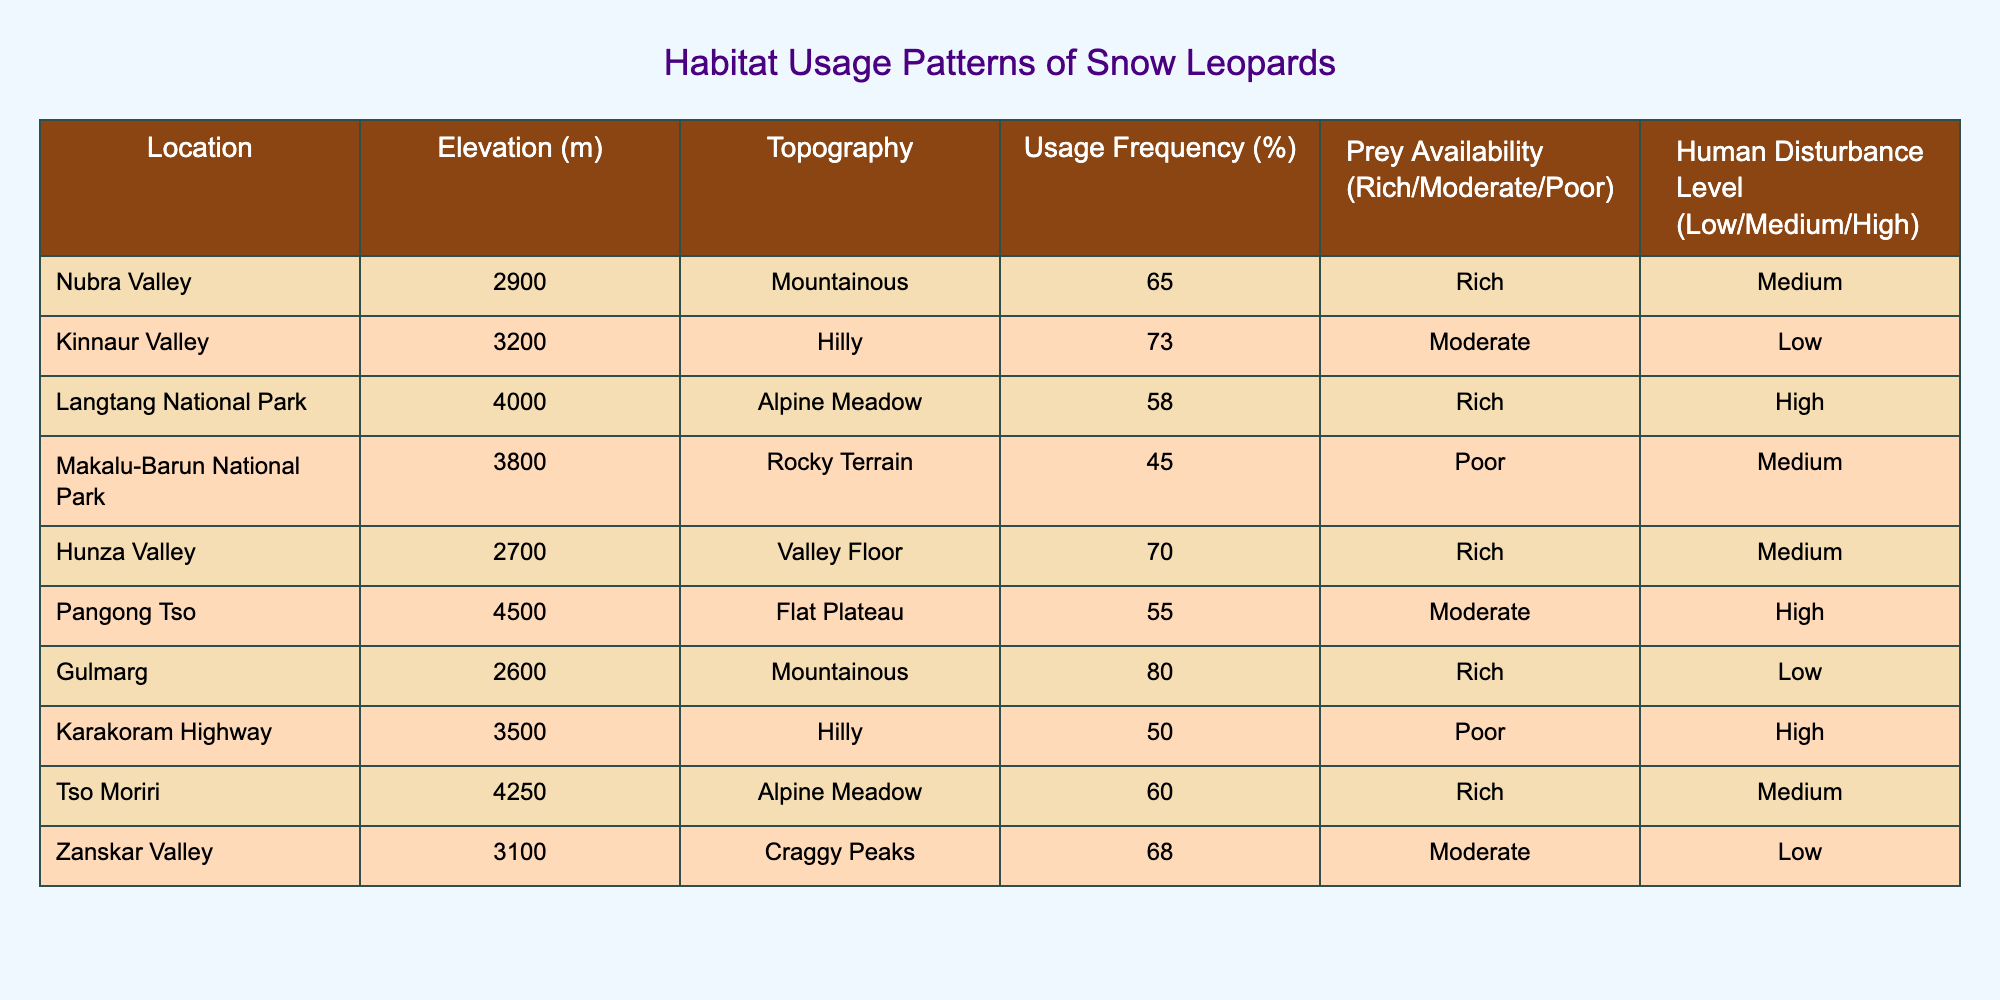What is the usage frequency percentage for snow leopards in Nubra Valley? The table lists the usage frequency for Nubra Valley under the "Usage Frequency (%)" column, which directly states that it is 65%.
Answer: 65% Which location has the highest usage frequency percentage? By comparing the usage frequency percentages listed for all locations, Gulmarg has the highest at 80%.
Answer: 80% How many locations have a "Rich" prey availability level? The locations listed with "Rich" prey availability are Nubra Valley, Langtang National Park, Hunza Valley, Gulmarg, Tso Moriri. This totals to 5 locations.
Answer: 5 What is the average elevation of the locations categorized as "Mountainous"? The elevations for mountainous locations are Nubra Valley (2900 m) and Gulmarg (2600 m). The average is calculated as (2900 + 2600) / 2 = 2750 m.
Answer: 2750 m Is Tso Moriri located in an area with high human disturbance? By examining the "Human Disturbance Level" column, Tso Moriri is listed as having a medium level of disturbance, which implies it is not categorized as high.
Answer: No Which location has the lowest usage frequency percentage and what is it? By reviewing the usage frequency percentages, Makalu-Barun National Park shows the lowest at 45%.
Answer: 45% What is the difference in usage frequency between the locations with "Rich" prey availability and the locations with "Poor" prey availability? The average usage frequency for locations with "Rich" prey (Nubra Valley 65%, Langtang National Park 58%, Hunza Valley 70%, Gulmarg 80%, Tso Moriri 60%) is (65 + 58 + 70 + 80 + 60) / 5 = 66.6%. The average for "Poor" prey (Makalu-Barun National Park 45% and Karakoram Highway 50%) is (45 + 50) / 2 = 47.5%. The difference is 66.6% - 47.5% = 19.1%.
Answer: 19.1% How many locations are in high human disturbance areas that also have moderate prey availability? By checking both "Human Disturbance Level" and "Prey Availability", only Langtang National Park fits both criteria as it is high disturbance and moderate prey. Thus, there is 1 location.
Answer: 1 Is the elevation of Pangong Tso higher than that of Kinnaur Valley? Comparing the elevations in the table, Pangong Tso is listed at 4500 m and Kinnaur Valley at 3200 m, which confirms that Pangong Tso is indeed at a higher elevation.
Answer: Yes 